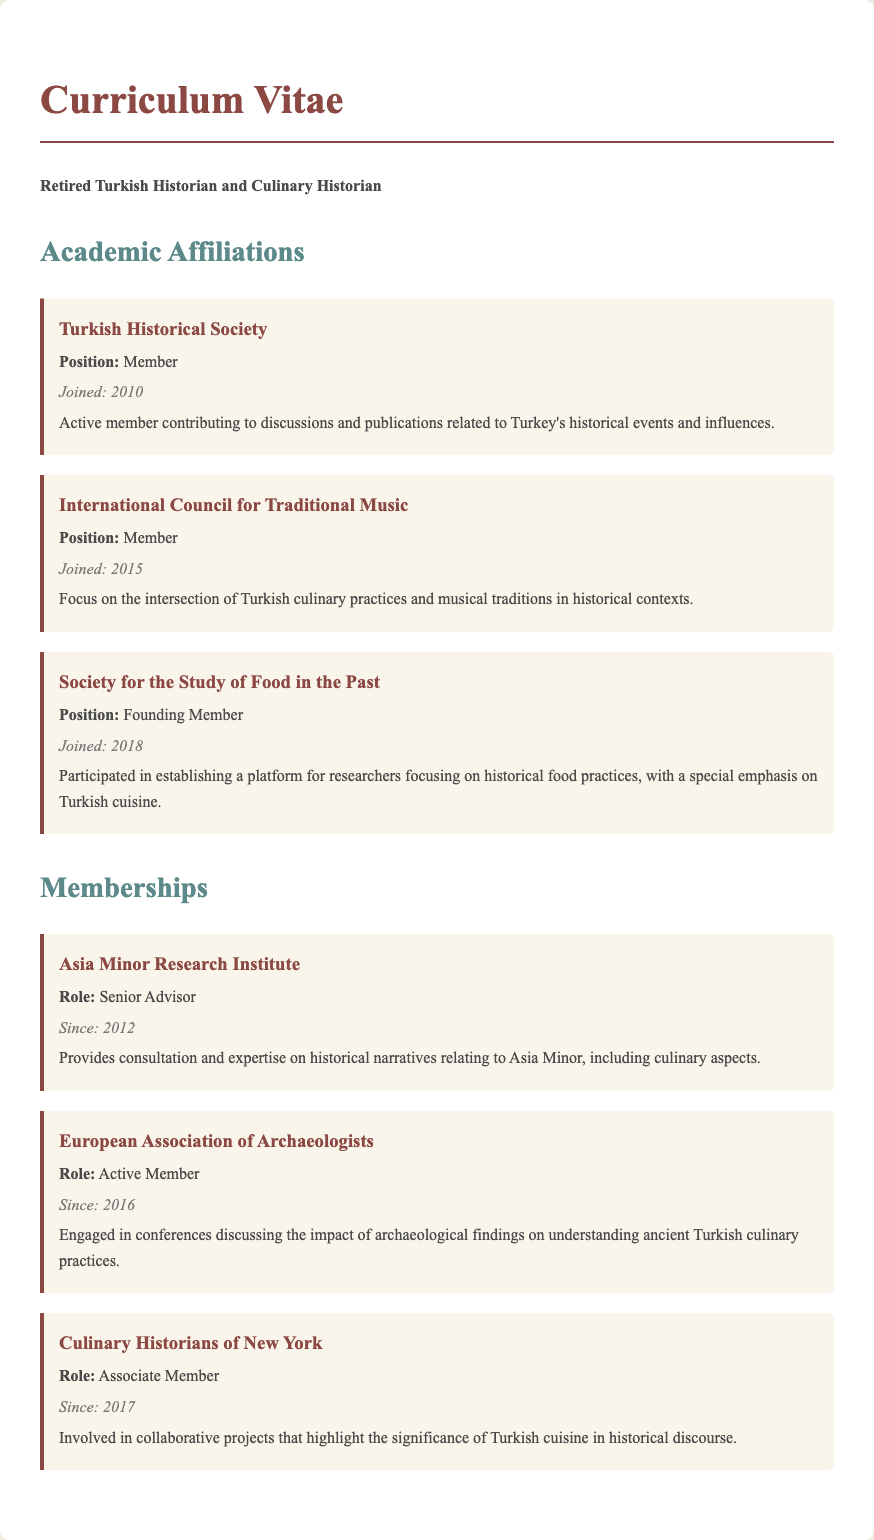What is the position in the Turkish Historical Society? The position in the Turkish Historical Society is stated as "Member."
Answer: Member When did the historian join the International Council for Traditional Music? The document specifies the year the historian joined as "2015."
Answer: 2015 What role does the historian hold at the Asia Minor Research Institute? The document mentions the role at the Asia Minor Research Institute as "Senior Advisor."
Answer: Senior Advisor What is the focus of the Society for the Study of Food in the Past? The document highlights that the focus is on "historical food practices," particularly emphasizing "Turkish cuisine."
Answer: historical food practices, Turkish cuisine How long has the historian been a member of the European Association of Archaeologists? The document states the membership began in "2016," so the duration is calculated based on the current year; if we assume 2023, it has been "7 years."
Answer: 7 years What type of member is the historian in the Culinary Historians of New York? The document indicates that the historian is an "Associate Member."
Answer: Associate Member Who are the key stakeholders in the Academic Affiliations section? The key stakeholders include organizations such as the "Turkish Historical Society," "International Council for Traditional Music," and "Society for the Study of Food in the Past."
Answer: Turkish Historical Society, International Council for Traditional Music, Society for the Study of Food in the Past What year was the Society for the Study of Food in the Past established? The document shows the historian joined in "2018," which typically indicates the year the society may have been established.
Answer: 2018 What area of expertise does the Asia Minor Research Institute focus on? The document states it provides expertise on "historical narratives relating to Asia Minor," which includes "culinary aspects."
Answer: historical narratives, culinary aspects 